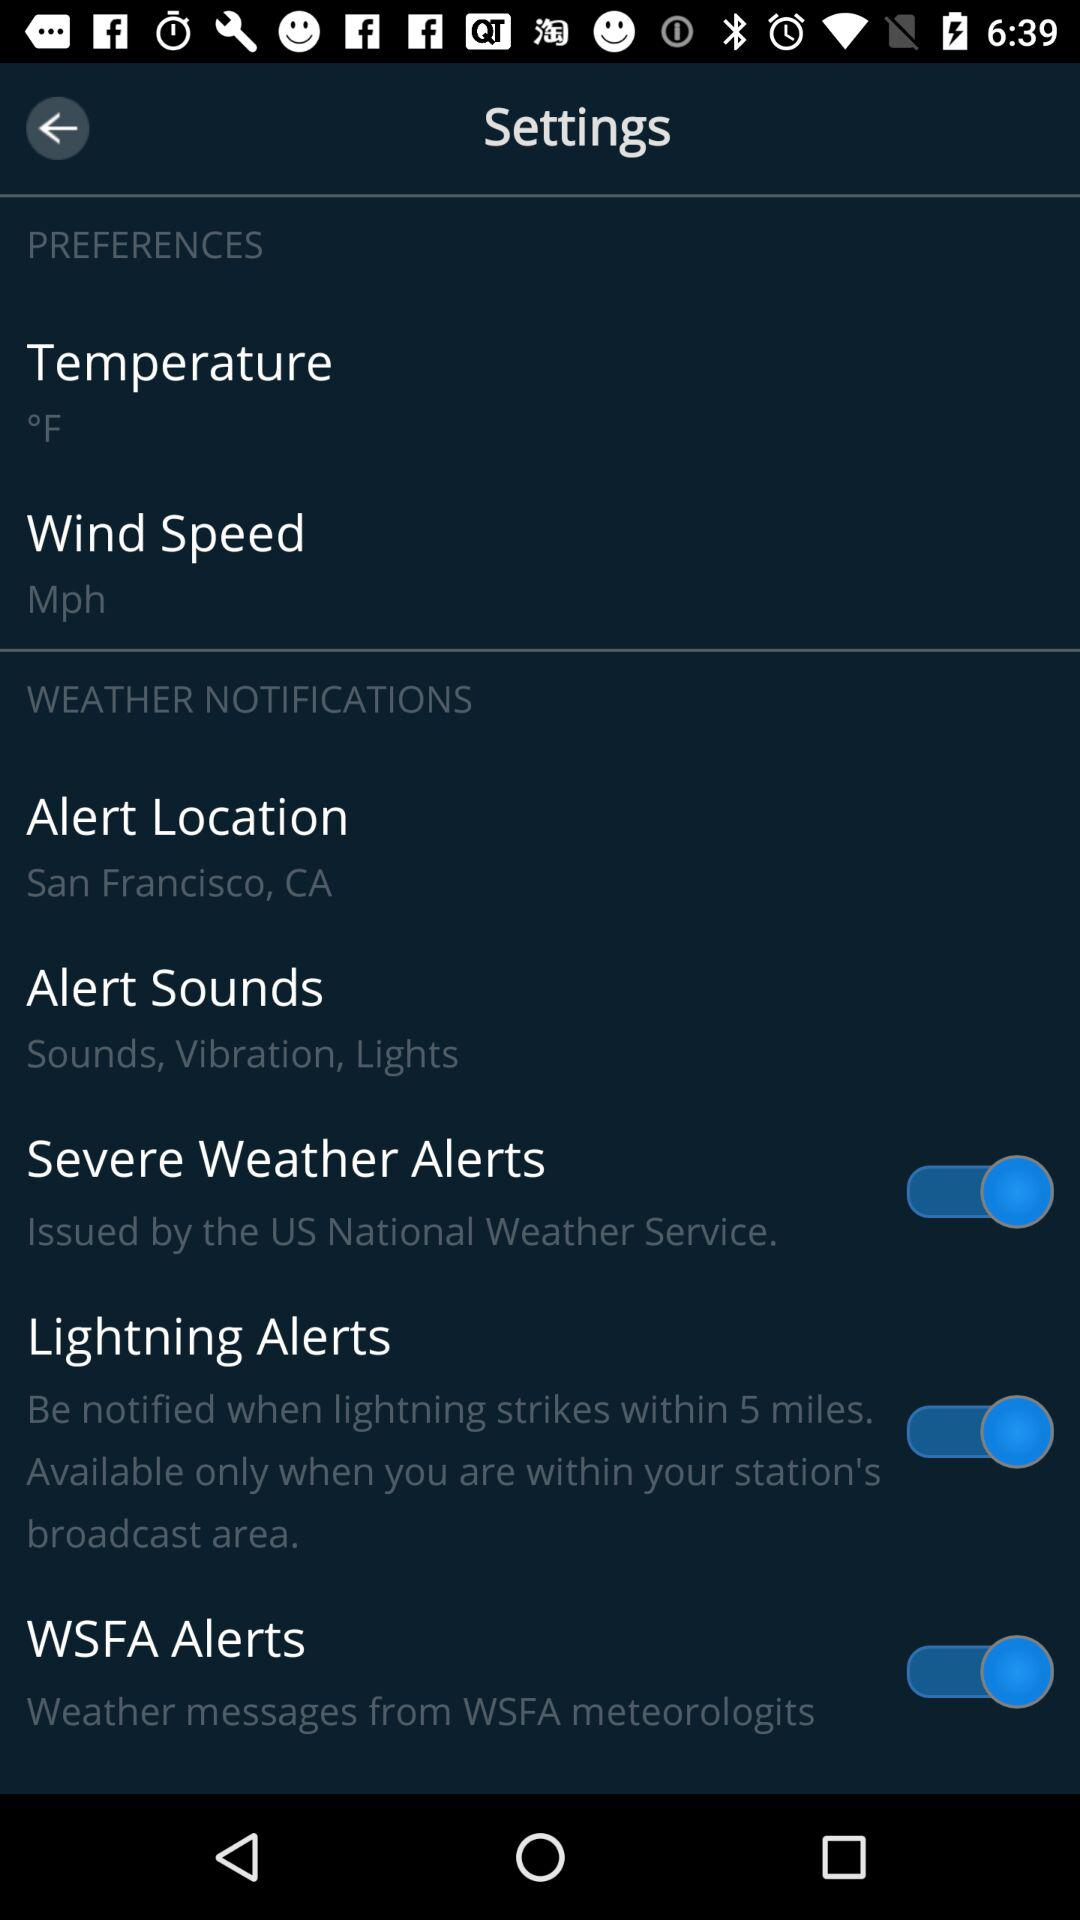What is the alert location? The alert location is San Francisco, CA. 